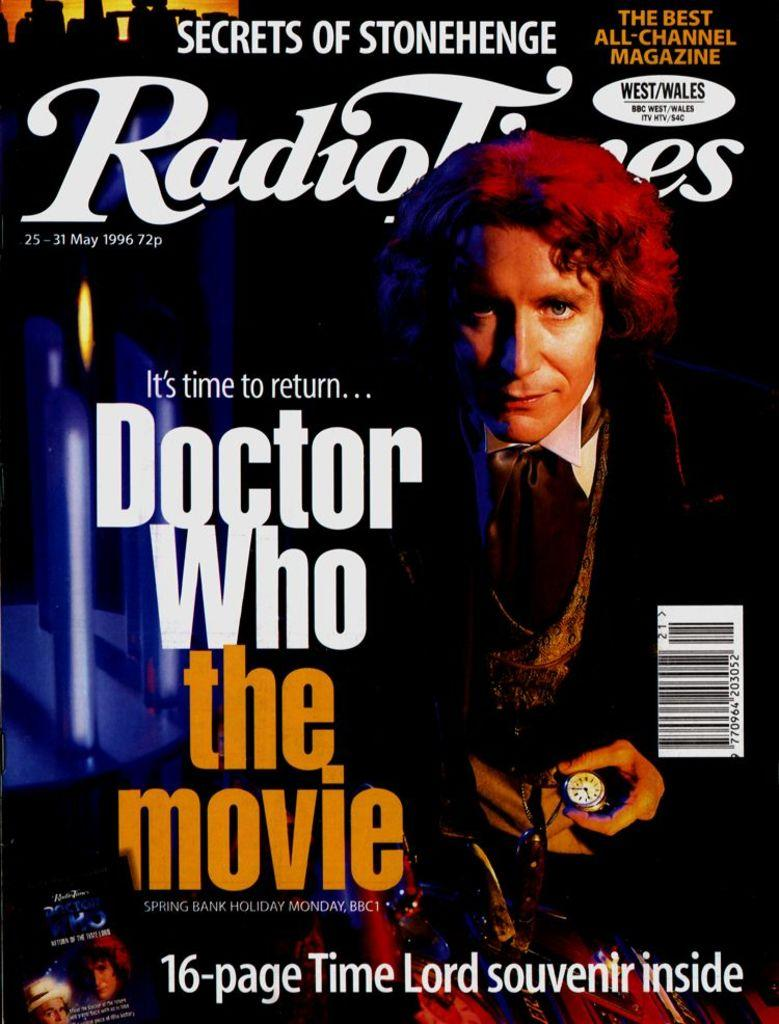<image>
Summarize the visual content of the image. A movie poster advertises the Doctor Who movie. 